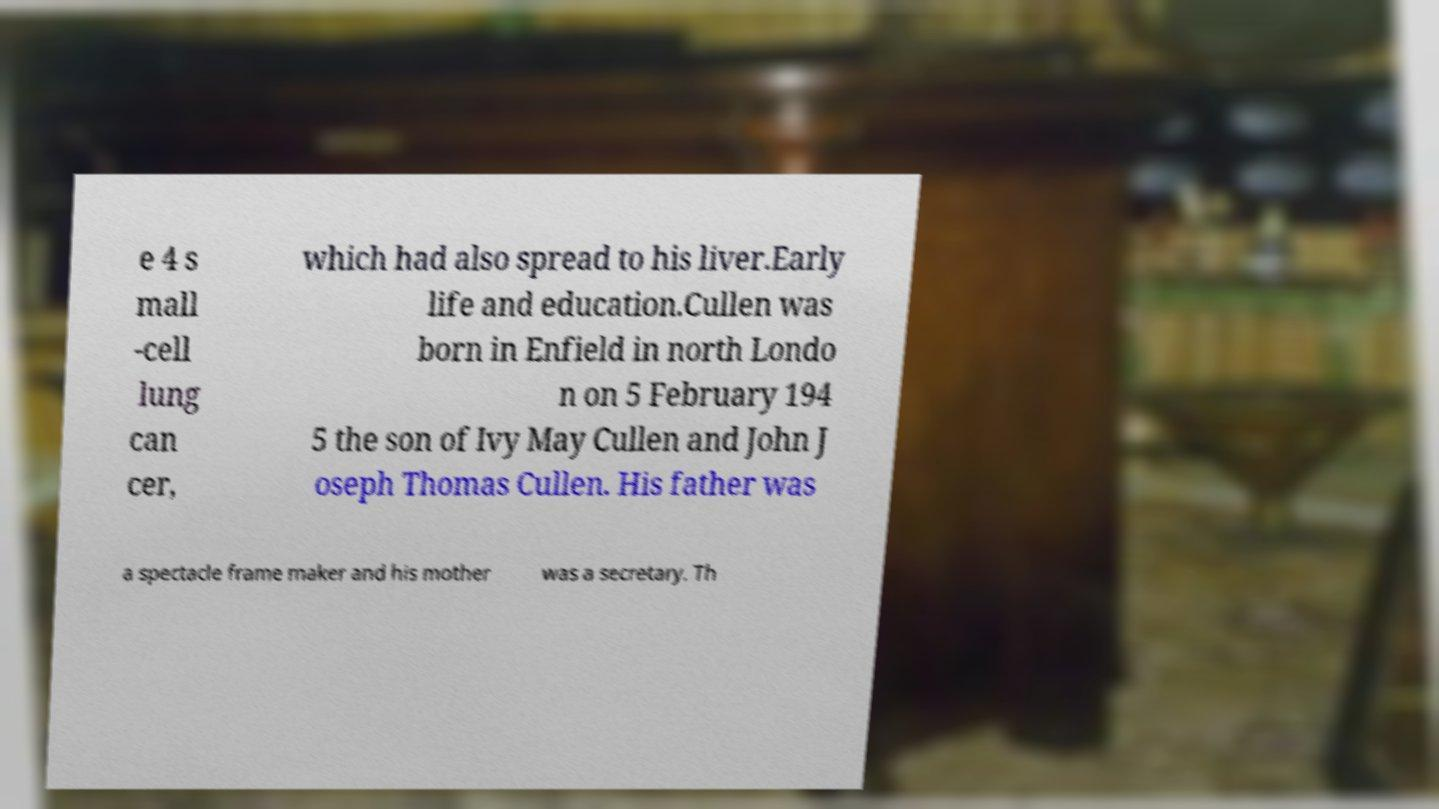There's text embedded in this image that I need extracted. Can you transcribe it verbatim? e 4 s mall -cell lung can cer, which had also spread to his liver.Early life and education.Cullen was born in Enfield in north Londo n on 5 February 194 5 the son of Ivy May Cullen and John J oseph Thomas Cullen. His father was a spectacle frame maker and his mother was a secretary. Th 